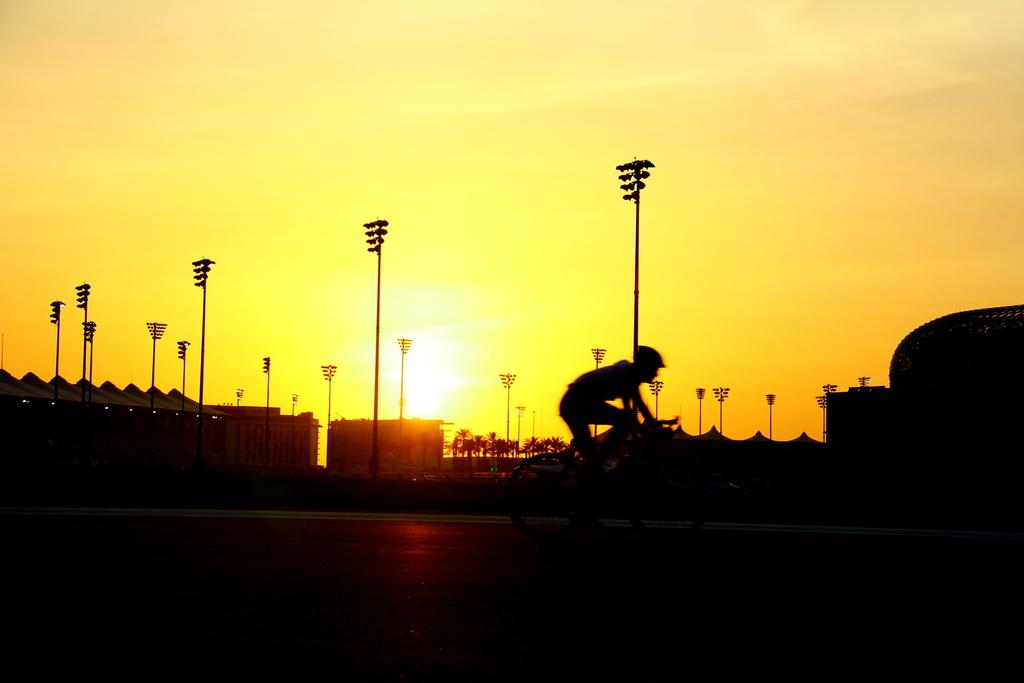What is the person in the image doing? There is a person sitting on a bicycle in the image. What can be seen in the distance behind the person? There are buildings, poles, trees, and sun rays visible in the background of the image. What type of branch is the person holding in the image? There is no branch present in the image; the person is sitting on a bicycle. 